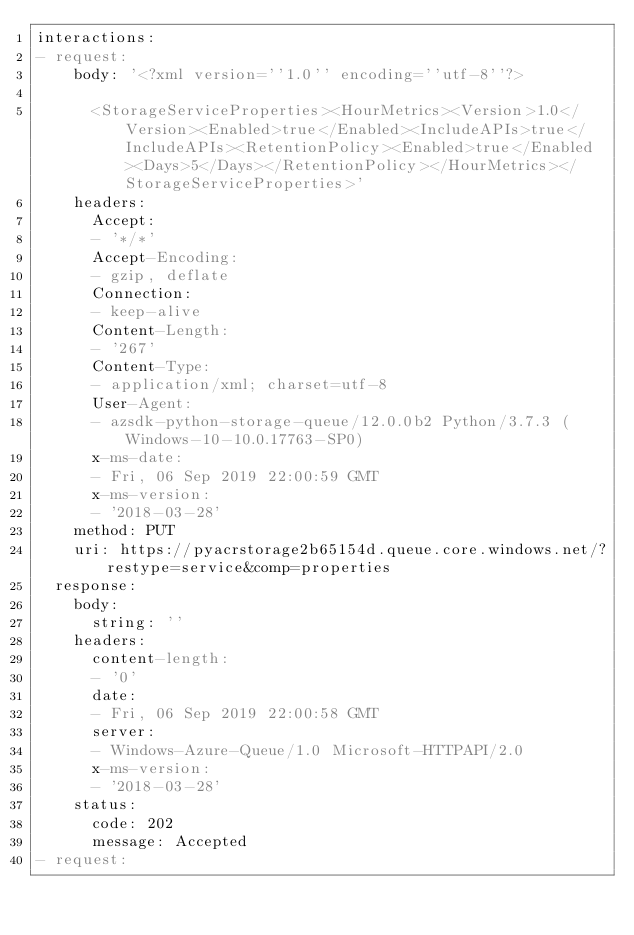Convert code to text. <code><loc_0><loc_0><loc_500><loc_500><_YAML_>interactions:
- request:
    body: '<?xml version=''1.0'' encoding=''utf-8''?>

      <StorageServiceProperties><HourMetrics><Version>1.0</Version><Enabled>true</Enabled><IncludeAPIs>true</IncludeAPIs><RetentionPolicy><Enabled>true</Enabled><Days>5</Days></RetentionPolicy></HourMetrics></StorageServiceProperties>'
    headers:
      Accept:
      - '*/*'
      Accept-Encoding:
      - gzip, deflate
      Connection:
      - keep-alive
      Content-Length:
      - '267'
      Content-Type:
      - application/xml; charset=utf-8
      User-Agent:
      - azsdk-python-storage-queue/12.0.0b2 Python/3.7.3 (Windows-10-10.0.17763-SP0)
      x-ms-date:
      - Fri, 06 Sep 2019 22:00:59 GMT
      x-ms-version:
      - '2018-03-28'
    method: PUT
    uri: https://pyacrstorage2b65154d.queue.core.windows.net/?restype=service&comp=properties
  response:
    body:
      string: ''
    headers:
      content-length:
      - '0'
      date:
      - Fri, 06 Sep 2019 22:00:58 GMT
      server:
      - Windows-Azure-Queue/1.0 Microsoft-HTTPAPI/2.0
      x-ms-version:
      - '2018-03-28'
    status:
      code: 202
      message: Accepted
- request:</code> 